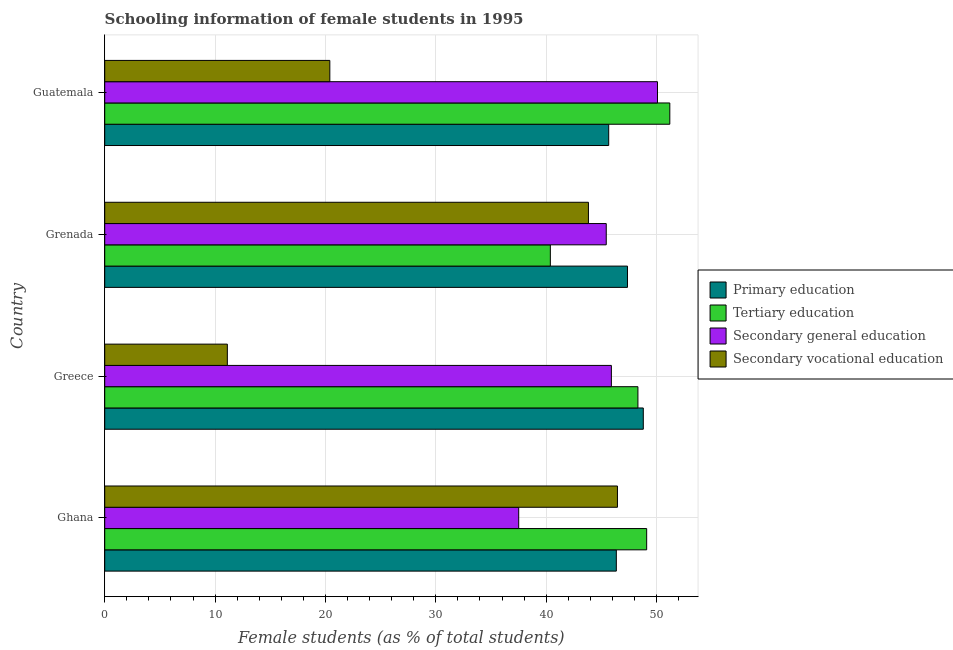How many bars are there on the 4th tick from the top?
Offer a very short reply. 4. What is the label of the 1st group of bars from the top?
Provide a succinct answer. Guatemala. In how many cases, is the number of bars for a given country not equal to the number of legend labels?
Offer a very short reply. 0. What is the percentage of female students in tertiary education in Greece?
Your answer should be very brief. 48.31. Across all countries, what is the maximum percentage of female students in secondary vocational education?
Offer a terse response. 46.46. Across all countries, what is the minimum percentage of female students in tertiary education?
Provide a short and direct response. 40.38. In which country was the percentage of female students in secondary education maximum?
Your answer should be compact. Guatemala. What is the total percentage of female students in primary education in the graph?
Make the answer very short. 188.2. What is the difference between the percentage of female students in secondary education in Grenada and that in Guatemala?
Ensure brevity in your answer.  -4.64. What is the difference between the percentage of female students in primary education in Grenada and the percentage of female students in tertiary education in Greece?
Give a very brief answer. -0.95. What is the average percentage of female students in secondary vocational education per country?
Your answer should be compact. 30.45. What is the difference between the percentage of female students in secondary vocational education and percentage of female students in tertiary education in Ghana?
Offer a very short reply. -2.65. In how many countries, is the percentage of female students in primary education greater than 44 %?
Your answer should be compact. 4. What is the ratio of the percentage of female students in primary education in Ghana to that in Greece?
Your answer should be compact. 0.95. Is the percentage of female students in secondary vocational education in Grenada less than that in Guatemala?
Your response must be concise. No. What is the difference between the highest and the second highest percentage of female students in tertiary education?
Your answer should be compact. 2.1. What is the difference between the highest and the lowest percentage of female students in primary education?
Keep it short and to the point. 3.14. Is the sum of the percentage of female students in secondary education in Ghana and Greece greater than the maximum percentage of female students in tertiary education across all countries?
Give a very brief answer. Yes. What does the 1st bar from the top in Ghana represents?
Provide a short and direct response. Secondary vocational education. What does the 3rd bar from the bottom in Guatemala represents?
Offer a very short reply. Secondary general education. Is it the case that in every country, the sum of the percentage of female students in primary education and percentage of female students in tertiary education is greater than the percentage of female students in secondary education?
Make the answer very short. Yes. How many bars are there?
Your answer should be compact. 16. Are all the bars in the graph horizontal?
Provide a short and direct response. Yes. What is the difference between two consecutive major ticks on the X-axis?
Your answer should be very brief. 10. Does the graph contain any zero values?
Your response must be concise. No. Where does the legend appear in the graph?
Offer a very short reply. Center right. How many legend labels are there?
Offer a very short reply. 4. What is the title of the graph?
Give a very brief answer. Schooling information of female students in 1995. What is the label or title of the X-axis?
Make the answer very short. Female students (as % of total students). What is the label or title of the Y-axis?
Provide a short and direct response. Country. What is the Female students (as % of total students) of Primary education in Ghana?
Ensure brevity in your answer.  46.36. What is the Female students (as % of total students) in Tertiary education in Ghana?
Offer a very short reply. 49.11. What is the Female students (as % of total students) of Secondary general education in Ghana?
Provide a short and direct response. 37.51. What is the Female students (as % of total students) of Secondary vocational education in Ghana?
Your response must be concise. 46.46. What is the Female students (as % of total students) of Primary education in Greece?
Your answer should be very brief. 48.8. What is the Female students (as % of total students) of Tertiary education in Greece?
Your response must be concise. 48.31. What is the Female students (as % of total students) in Secondary general education in Greece?
Keep it short and to the point. 45.91. What is the Female students (as % of total students) in Secondary vocational education in Greece?
Ensure brevity in your answer.  11.11. What is the Female students (as % of total students) in Primary education in Grenada?
Offer a terse response. 47.37. What is the Female students (as % of total students) in Tertiary education in Grenada?
Provide a succinct answer. 40.38. What is the Female students (as % of total students) of Secondary general education in Grenada?
Make the answer very short. 45.44. What is the Female students (as % of total students) in Secondary vocational education in Grenada?
Give a very brief answer. 43.83. What is the Female students (as % of total students) of Primary education in Guatemala?
Your response must be concise. 45.67. What is the Female students (as % of total students) of Tertiary education in Guatemala?
Provide a succinct answer. 51.21. What is the Female students (as % of total students) of Secondary general education in Guatemala?
Keep it short and to the point. 50.09. What is the Female students (as % of total students) in Secondary vocational education in Guatemala?
Your response must be concise. 20.4. Across all countries, what is the maximum Female students (as % of total students) of Primary education?
Your response must be concise. 48.8. Across all countries, what is the maximum Female students (as % of total students) of Tertiary education?
Your answer should be very brief. 51.21. Across all countries, what is the maximum Female students (as % of total students) in Secondary general education?
Make the answer very short. 50.09. Across all countries, what is the maximum Female students (as % of total students) in Secondary vocational education?
Your answer should be compact. 46.46. Across all countries, what is the minimum Female students (as % of total students) of Primary education?
Provide a succinct answer. 45.67. Across all countries, what is the minimum Female students (as % of total students) in Tertiary education?
Keep it short and to the point. 40.38. Across all countries, what is the minimum Female students (as % of total students) in Secondary general education?
Provide a short and direct response. 37.51. Across all countries, what is the minimum Female students (as % of total students) in Secondary vocational education?
Your answer should be very brief. 11.11. What is the total Female students (as % of total students) in Primary education in the graph?
Give a very brief answer. 188.2. What is the total Female students (as % of total students) of Tertiary education in the graph?
Your answer should be very brief. 189.01. What is the total Female students (as % of total students) in Secondary general education in the graph?
Your answer should be very brief. 178.95. What is the total Female students (as % of total students) in Secondary vocational education in the graph?
Your response must be concise. 121.8. What is the difference between the Female students (as % of total students) in Primary education in Ghana and that in Greece?
Offer a very short reply. -2.44. What is the difference between the Female students (as % of total students) of Tertiary education in Ghana and that in Greece?
Your response must be concise. 0.79. What is the difference between the Female students (as % of total students) in Secondary general education in Ghana and that in Greece?
Your answer should be compact. -8.4. What is the difference between the Female students (as % of total students) of Secondary vocational education in Ghana and that in Greece?
Your answer should be compact. 35.35. What is the difference between the Female students (as % of total students) of Primary education in Ghana and that in Grenada?
Make the answer very short. -1.01. What is the difference between the Female students (as % of total students) of Tertiary education in Ghana and that in Grenada?
Provide a short and direct response. 8.73. What is the difference between the Female students (as % of total students) in Secondary general education in Ghana and that in Grenada?
Give a very brief answer. -7.93. What is the difference between the Female students (as % of total students) in Secondary vocational education in Ghana and that in Grenada?
Your answer should be compact. 2.63. What is the difference between the Female students (as % of total students) of Primary education in Ghana and that in Guatemala?
Your answer should be very brief. 0.69. What is the difference between the Female students (as % of total students) in Tertiary education in Ghana and that in Guatemala?
Make the answer very short. -2.1. What is the difference between the Female students (as % of total students) of Secondary general education in Ghana and that in Guatemala?
Offer a very short reply. -12.57. What is the difference between the Female students (as % of total students) in Secondary vocational education in Ghana and that in Guatemala?
Offer a very short reply. 26.06. What is the difference between the Female students (as % of total students) in Primary education in Greece and that in Grenada?
Ensure brevity in your answer.  1.43. What is the difference between the Female students (as % of total students) of Tertiary education in Greece and that in Grenada?
Make the answer very short. 7.94. What is the difference between the Female students (as % of total students) in Secondary general education in Greece and that in Grenada?
Make the answer very short. 0.46. What is the difference between the Female students (as % of total students) in Secondary vocational education in Greece and that in Grenada?
Provide a short and direct response. -32.72. What is the difference between the Female students (as % of total students) of Primary education in Greece and that in Guatemala?
Ensure brevity in your answer.  3.14. What is the difference between the Female students (as % of total students) in Tertiary education in Greece and that in Guatemala?
Ensure brevity in your answer.  -2.89. What is the difference between the Female students (as % of total students) in Secondary general education in Greece and that in Guatemala?
Make the answer very short. -4.18. What is the difference between the Female students (as % of total students) in Secondary vocational education in Greece and that in Guatemala?
Offer a very short reply. -9.29. What is the difference between the Female students (as % of total students) in Primary education in Grenada and that in Guatemala?
Your response must be concise. 1.7. What is the difference between the Female students (as % of total students) in Tertiary education in Grenada and that in Guatemala?
Give a very brief answer. -10.83. What is the difference between the Female students (as % of total students) in Secondary general education in Grenada and that in Guatemala?
Keep it short and to the point. -4.64. What is the difference between the Female students (as % of total students) of Secondary vocational education in Grenada and that in Guatemala?
Your answer should be very brief. 23.43. What is the difference between the Female students (as % of total students) in Primary education in Ghana and the Female students (as % of total students) in Tertiary education in Greece?
Offer a very short reply. -1.96. What is the difference between the Female students (as % of total students) of Primary education in Ghana and the Female students (as % of total students) of Secondary general education in Greece?
Keep it short and to the point. 0.45. What is the difference between the Female students (as % of total students) in Primary education in Ghana and the Female students (as % of total students) in Secondary vocational education in Greece?
Your answer should be compact. 35.25. What is the difference between the Female students (as % of total students) of Tertiary education in Ghana and the Female students (as % of total students) of Secondary general education in Greece?
Your answer should be compact. 3.2. What is the difference between the Female students (as % of total students) of Tertiary education in Ghana and the Female students (as % of total students) of Secondary vocational education in Greece?
Offer a very short reply. 38. What is the difference between the Female students (as % of total students) of Secondary general education in Ghana and the Female students (as % of total students) of Secondary vocational education in Greece?
Provide a succinct answer. 26.4. What is the difference between the Female students (as % of total students) of Primary education in Ghana and the Female students (as % of total students) of Tertiary education in Grenada?
Ensure brevity in your answer.  5.98. What is the difference between the Female students (as % of total students) of Primary education in Ghana and the Female students (as % of total students) of Secondary general education in Grenada?
Your answer should be compact. 0.91. What is the difference between the Female students (as % of total students) in Primary education in Ghana and the Female students (as % of total students) in Secondary vocational education in Grenada?
Offer a terse response. 2.53. What is the difference between the Female students (as % of total students) in Tertiary education in Ghana and the Female students (as % of total students) in Secondary general education in Grenada?
Ensure brevity in your answer.  3.66. What is the difference between the Female students (as % of total students) of Tertiary education in Ghana and the Female students (as % of total students) of Secondary vocational education in Grenada?
Your answer should be very brief. 5.28. What is the difference between the Female students (as % of total students) in Secondary general education in Ghana and the Female students (as % of total students) in Secondary vocational education in Grenada?
Keep it short and to the point. -6.32. What is the difference between the Female students (as % of total students) of Primary education in Ghana and the Female students (as % of total students) of Tertiary education in Guatemala?
Your answer should be compact. -4.85. What is the difference between the Female students (as % of total students) of Primary education in Ghana and the Female students (as % of total students) of Secondary general education in Guatemala?
Give a very brief answer. -3.73. What is the difference between the Female students (as % of total students) in Primary education in Ghana and the Female students (as % of total students) in Secondary vocational education in Guatemala?
Offer a very short reply. 25.96. What is the difference between the Female students (as % of total students) of Tertiary education in Ghana and the Female students (as % of total students) of Secondary general education in Guatemala?
Make the answer very short. -0.98. What is the difference between the Female students (as % of total students) of Tertiary education in Ghana and the Female students (as % of total students) of Secondary vocational education in Guatemala?
Offer a terse response. 28.71. What is the difference between the Female students (as % of total students) in Secondary general education in Ghana and the Female students (as % of total students) in Secondary vocational education in Guatemala?
Ensure brevity in your answer.  17.11. What is the difference between the Female students (as % of total students) in Primary education in Greece and the Female students (as % of total students) in Tertiary education in Grenada?
Your response must be concise. 8.42. What is the difference between the Female students (as % of total students) of Primary education in Greece and the Female students (as % of total students) of Secondary general education in Grenada?
Provide a succinct answer. 3.36. What is the difference between the Female students (as % of total students) of Primary education in Greece and the Female students (as % of total students) of Secondary vocational education in Grenada?
Give a very brief answer. 4.97. What is the difference between the Female students (as % of total students) of Tertiary education in Greece and the Female students (as % of total students) of Secondary general education in Grenada?
Your response must be concise. 2.87. What is the difference between the Female students (as % of total students) in Tertiary education in Greece and the Female students (as % of total students) in Secondary vocational education in Grenada?
Offer a very short reply. 4.48. What is the difference between the Female students (as % of total students) in Secondary general education in Greece and the Female students (as % of total students) in Secondary vocational education in Grenada?
Your response must be concise. 2.08. What is the difference between the Female students (as % of total students) of Primary education in Greece and the Female students (as % of total students) of Tertiary education in Guatemala?
Offer a very short reply. -2.4. What is the difference between the Female students (as % of total students) in Primary education in Greece and the Female students (as % of total students) in Secondary general education in Guatemala?
Make the answer very short. -1.28. What is the difference between the Female students (as % of total students) of Primary education in Greece and the Female students (as % of total students) of Secondary vocational education in Guatemala?
Give a very brief answer. 28.4. What is the difference between the Female students (as % of total students) of Tertiary education in Greece and the Female students (as % of total students) of Secondary general education in Guatemala?
Offer a terse response. -1.77. What is the difference between the Female students (as % of total students) of Tertiary education in Greece and the Female students (as % of total students) of Secondary vocational education in Guatemala?
Give a very brief answer. 27.92. What is the difference between the Female students (as % of total students) in Secondary general education in Greece and the Female students (as % of total students) in Secondary vocational education in Guatemala?
Keep it short and to the point. 25.51. What is the difference between the Female students (as % of total students) in Primary education in Grenada and the Female students (as % of total students) in Tertiary education in Guatemala?
Provide a short and direct response. -3.84. What is the difference between the Female students (as % of total students) in Primary education in Grenada and the Female students (as % of total students) in Secondary general education in Guatemala?
Your response must be concise. -2.72. What is the difference between the Female students (as % of total students) in Primary education in Grenada and the Female students (as % of total students) in Secondary vocational education in Guatemala?
Ensure brevity in your answer.  26.97. What is the difference between the Female students (as % of total students) of Tertiary education in Grenada and the Female students (as % of total students) of Secondary general education in Guatemala?
Give a very brief answer. -9.71. What is the difference between the Female students (as % of total students) in Tertiary education in Grenada and the Female students (as % of total students) in Secondary vocational education in Guatemala?
Provide a succinct answer. 19.98. What is the difference between the Female students (as % of total students) of Secondary general education in Grenada and the Female students (as % of total students) of Secondary vocational education in Guatemala?
Provide a short and direct response. 25.05. What is the average Female students (as % of total students) in Primary education per country?
Offer a terse response. 47.05. What is the average Female students (as % of total students) of Tertiary education per country?
Offer a terse response. 47.25. What is the average Female students (as % of total students) in Secondary general education per country?
Make the answer very short. 44.74. What is the average Female students (as % of total students) in Secondary vocational education per country?
Offer a very short reply. 30.45. What is the difference between the Female students (as % of total students) of Primary education and Female students (as % of total students) of Tertiary education in Ghana?
Provide a short and direct response. -2.75. What is the difference between the Female students (as % of total students) of Primary education and Female students (as % of total students) of Secondary general education in Ghana?
Your answer should be compact. 8.85. What is the difference between the Female students (as % of total students) in Primary education and Female students (as % of total students) in Secondary vocational education in Ghana?
Your response must be concise. -0.1. What is the difference between the Female students (as % of total students) of Tertiary education and Female students (as % of total students) of Secondary general education in Ghana?
Give a very brief answer. 11.59. What is the difference between the Female students (as % of total students) of Tertiary education and Female students (as % of total students) of Secondary vocational education in Ghana?
Ensure brevity in your answer.  2.65. What is the difference between the Female students (as % of total students) of Secondary general education and Female students (as % of total students) of Secondary vocational education in Ghana?
Make the answer very short. -8.95. What is the difference between the Female students (as % of total students) in Primary education and Female students (as % of total students) in Tertiary education in Greece?
Your response must be concise. 0.49. What is the difference between the Female students (as % of total students) of Primary education and Female students (as % of total students) of Secondary general education in Greece?
Make the answer very short. 2.89. What is the difference between the Female students (as % of total students) of Primary education and Female students (as % of total students) of Secondary vocational education in Greece?
Your answer should be very brief. 37.69. What is the difference between the Female students (as % of total students) of Tertiary education and Female students (as % of total students) of Secondary general education in Greece?
Offer a very short reply. 2.41. What is the difference between the Female students (as % of total students) in Tertiary education and Female students (as % of total students) in Secondary vocational education in Greece?
Ensure brevity in your answer.  37.2. What is the difference between the Female students (as % of total students) of Secondary general education and Female students (as % of total students) of Secondary vocational education in Greece?
Offer a very short reply. 34.8. What is the difference between the Female students (as % of total students) in Primary education and Female students (as % of total students) in Tertiary education in Grenada?
Provide a succinct answer. 6.99. What is the difference between the Female students (as % of total students) of Primary education and Female students (as % of total students) of Secondary general education in Grenada?
Your response must be concise. 1.93. What is the difference between the Female students (as % of total students) of Primary education and Female students (as % of total students) of Secondary vocational education in Grenada?
Keep it short and to the point. 3.54. What is the difference between the Female students (as % of total students) of Tertiary education and Female students (as % of total students) of Secondary general education in Grenada?
Give a very brief answer. -5.07. What is the difference between the Female students (as % of total students) in Tertiary education and Female students (as % of total students) in Secondary vocational education in Grenada?
Offer a terse response. -3.45. What is the difference between the Female students (as % of total students) of Secondary general education and Female students (as % of total students) of Secondary vocational education in Grenada?
Keep it short and to the point. 1.61. What is the difference between the Female students (as % of total students) in Primary education and Female students (as % of total students) in Tertiary education in Guatemala?
Keep it short and to the point. -5.54. What is the difference between the Female students (as % of total students) in Primary education and Female students (as % of total students) in Secondary general education in Guatemala?
Your response must be concise. -4.42. What is the difference between the Female students (as % of total students) of Primary education and Female students (as % of total students) of Secondary vocational education in Guatemala?
Your answer should be compact. 25.27. What is the difference between the Female students (as % of total students) in Tertiary education and Female students (as % of total students) in Secondary general education in Guatemala?
Provide a succinct answer. 1.12. What is the difference between the Female students (as % of total students) in Tertiary education and Female students (as % of total students) in Secondary vocational education in Guatemala?
Your answer should be compact. 30.81. What is the difference between the Female students (as % of total students) of Secondary general education and Female students (as % of total students) of Secondary vocational education in Guatemala?
Offer a very short reply. 29.69. What is the ratio of the Female students (as % of total students) of Primary education in Ghana to that in Greece?
Your answer should be very brief. 0.95. What is the ratio of the Female students (as % of total students) in Tertiary education in Ghana to that in Greece?
Provide a succinct answer. 1.02. What is the ratio of the Female students (as % of total students) of Secondary general education in Ghana to that in Greece?
Keep it short and to the point. 0.82. What is the ratio of the Female students (as % of total students) in Secondary vocational education in Ghana to that in Greece?
Offer a terse response. 4.18. What is the ratio of the Female students (as % of total students) of Primary education in Ghana to that in Grenada?
Give a very brief answer. 0.98. What is the ratio of the Female students (as % of total students) in Tertiary education in Ghana to that in Grenada?
Keep it short and to the point. 1.22. What is the ratio of the Female students (as % of total students) of Secondary general education in Ghana to that in Grenada?
Make the answer very short. 0.83. What is the ratio of the Female students (as % of total students) in Secondary vocational education in Ghana to that in Grenada?
Provide a short and direct response. 1.06. What is the ratio of the Female students (as % of total students) of Primary education in Ghana to that in Guatemala?
Offer a terse response. 1.02. What is the ratio of the Female students (as % of total students) in Tertiary education in Ghana to that in Guatemala?
Keep it short and to the point. 0.96. What is the ratio of the Female students (as % of total students) in Secondary general education in Ghana to that in Guatemala?
Your response must be concise. 0.75. What is the ratio of the Female students (as % of total students) in Secondary vocational education in Ghana to that in Guatemala?
Keep it short and to the point. 2.28. What is the ratio of the Female students (as % of total students) in Primary education in Greece to that in Grenada?
Your response must be concise. 1.03. What is the ratio of the Female students (as % of total students) of Tertiary education in Greece to that in Grenada?
Ensure brevity in your answer.  1.2. What is the ratio of the Female students (as % of total students) of Secondary general education in Greece to that in Grenada?
Keep it short and to the point. 1.01. What is the ratio of the Female students (as % of total students) of Secondary vocational education in Greece to that in Grenada?
Your response must be concise. 0.25. What is the ratio of the Female students (as % of total students) of Primary education in Greece to that in Guatemala?
Offer a very short reply. 1.07. What is the ratio of the Female students (as % of total students) in Tertiary education in Greece to that in Guatemala?
Offer a terse response. 0.94. What is the ratio of the Female students (as % of total students) in Secondary general education in Greece to that in Guatemala?
Your response must be concise. 0.92. What is the ratio of the Female students (as % of total students) in Secondary vocational education in Greece to that in Guatemala?
Ensure brevity in your answer.  0.54. What is the ratio of the Female students (as % of total students) of Primary education in Grenada to that in Guatemala?
Your answer should be very brief. 1.04. What is the ratio of the Female students (as % of total students) in Tertiary education in Grenada to that in Guatemala?
Give a very brief answer. 0.79. What is the ratio of the Female students (as % of total students) of Secondary general education in Grenada to that in Guatemala?
Ensure brevity in your answer.  0.91. What is the ratio of the Female students (as % of total students) in Secondary vocational education in Grenada to that in Guatemala?
Provide a succinct answer. 2.15. What is the difference between the highest and the second highest Female students (as % of total students) of Primary education?
Provide a succinct answer. 1.43. What is the difference between the highest and the second highest Female students (as % of total students) in Tertiary education?
Offer a terse response. 2.1. What is the difference between the highest and the second highest Female students (as % of total students) in Secondary general education?
Offer a terse response. 4.18. What is the difference between the highest and the second highest Female students (as % of total students) of Secondary vocational education?
Your answer should be very brief. 2.63. What is the difference between the highest and the lowest Female students (as % of total students) of Primary education?
Offer a very short reply. 3.14. What is the difference between the highest and the lowest Female students (as % of total students) in Tertiary education?
Offer a very short reply. 10.83. What is the difference between the highest and the lowest Female students (as % of total students) of Secondary general education?
Your response must be concise. 12.57. What is the difference between the highest and the lowest Female students (as % of total students) of Secondary vocational education?
Keep it short and to the point. 35.35. 